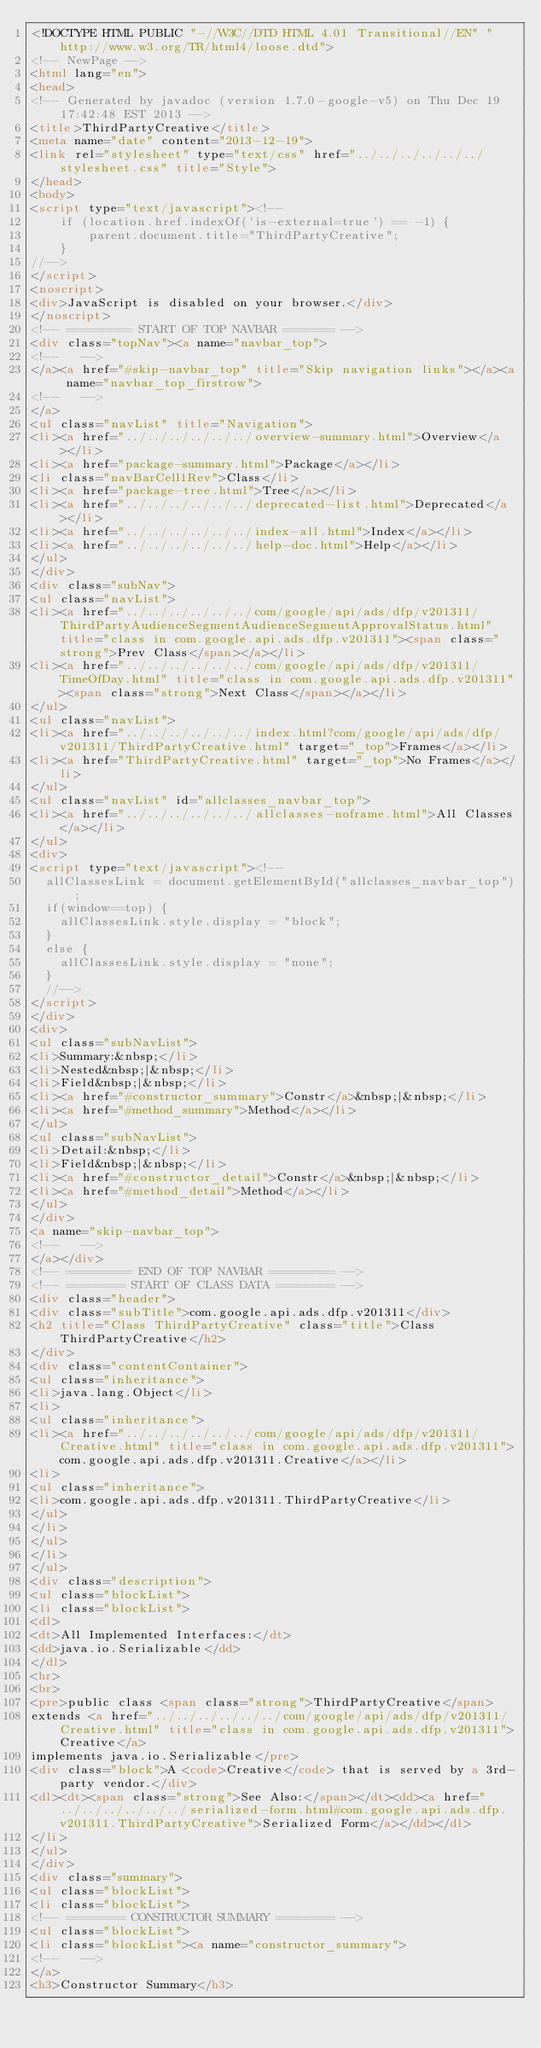<code> <loc_0><loc_0><loc_500><loc_500><_HTML_><!DOCTYPE HTML PUBLIC "-//W3C//DTD HTML 4.01 Transitional//EN" "http://www.w3.org/TR/html4/loose.dtd">
<!-- NewPage -->
<html lang="en">
<head>
<!-- Generated by javadoc (version 1.7.0-google-v5) on Thu Dec 19 17:42:48 EST 2013 -->
<title>ThirdPartyCreative</title>
<meta name="date" content="2013-12-19">
<link rel="stylesheet" type="text/css" href="../../../../../../stylesheet.css" title="Style">
</head>
<body>
<script type="text/javascript"><!--
    if (location.href.indexOf('is-external=true') == -1) {
        parent.document.title="ThirdPartyCreative";
    }
//-->
</script>
<noscript>
<div>JavaScript is disabled on your browser.</div>
</noscript>
<!-- ========= START OF TOP NAVBAR ======= -->
<div class="topNav"><a name="navbar_top">
<!--   -->
</a><a href="#skip-navbar_top" title="Skip navigation links"></a><a name="navbar_top_firstrow">
<!--   -->
</a>
<ul class="navList" title="Navigation">
<li><a href="../../../../../../overview-summary.html">Overview</a></li>
<li><a href="package-summary.html">Package</a></li>
<li class="navBarCell1Rev">Class</li>
<li><a href="package-tree.html">Tree</a></li>
<li><a href="../../../../../../deprecated-list.html">Deprecated</a></li>
<li><a href="../../../../../../index-all.html">Index</a></li>
<li><a href="../../../../../../help-doc.html">Help</a></li>
</ul>
</div>
<div class="subNav">
<ul class="navList">
<li><a href="../../../../../../com/google/api/ads/dfp/v201311/ThirdPartyAudienceSegmentAudienceSegmentApprovalStatus.html" title="class in com.google.api.ads.dfp.v201311"><span class="strong">Prev Class</span></a></li>
<li><a href="../../../../../../com/google/api/ads/dfp/v201311/TimeOfDay.html" title="class in com.google.api.ads.dfp.v201311"><span class="strong">Next Class</span></a></li>
</ul>
<ul class="navList">
<li><a href="../../../../../../index.html?com/google/api/ads/dfp/v201311/ThirdPartyCreative.html" target="_top">Frames</a></li>
<li><a href="ThirdPartyCreative.html" target="_top">No Frames</a></li>
</ul>
<ul class="navList" id="allclasses_navbar_top">
<li><a href="../../../../../../allclasses-noframe.html">All Classes</a></li>
</ul>
<div>
<script type="text/javascript"><!--
  allClassesLink = document.getElementById("allclasses_navbar_top");
  if(window==top) {
    allClassesLink.style.display = "block";
  }
  else {
    allClassesLink.style.display = "none";
  }
  //-->
</script>
</div>
<div>
<ul class="subNavList">
<li>Summary:&nbsp;</li>
<li>Nested&nbsp;|&nbsp;</li>
<li>Field&nbsp;|&nbsp;</li>
<li><a href="#constructor_summary">Constr</a>&nbsp;|&nbsp;</li>
<li><a href="#method_summary">Method</a></li>
</ul>
<ul class="subNavList">
<li>Detail:&nbsp;</li>
<li>Field&nbsp;|&nbsp;</li>
<li><a href="#constructor_detail">Constr</a>&nbsp;|&nbsp;</li>
<li><a href="#method_detail">Method</a></li>
</ul>
</div>
<a name="skip-navbar_top">
<!--   -->
</a></div>
<!-- ========= END OF TOP NAVBAR ========= -->
<!-- ======== START OF CLASS DATA ======== -->
<div class="header">
<div class="subTitle">com.google.api.ads.dfp.v201311</div>
<h2 title="Class ThirdPartyCreative" class="title">Class ThirdPartyCreative</h2>
</div>
<div class="contentContainer">
<ul class="inheritance">
<li>java.lang.Object</li>
<li>
<ul class="inheritance">
<li><a href="../../../../../../com/google/api/ads/dfp/v201311/Creative.html" title="class in com.google.api.ads.dfp.v201311">com.google.api.ads.dfp.v201311.Creative</a></li>
<li>
<ul class="inheritance">
<li>com.google.api.ads.dfp.v201311.ThirdPartyCreative</li>
</ul>
</li>
</ul>
</li>
</ul>
<div class="description">
<ul class="blockList">
<li class="blockList">
<dl>
<dt>All Implemented Interfaces:</dt>
<dd>java.io.Serializable</dd>
</dl>
<hr>
<br>
<pre>public class <span class="strong">ThirdPartyCreative</span>
extends <a href="../../../../../../com/google/api/ads/dfp/v201311/Creative.html" title="class in com.google.api.ads.dfp.v201311">Creative</a>
implements java.io.Serializable</pre>
<div class="block">A <code>Creative</code> that is served by a 3rd-party vendor.</div>
<dl><dt><span class="strong">See Also:</span></dt><dd><a href="../../../../../../serialized-form.html#com.google.api.ads.dfp.v201311.ThirdPartyCreative">Serialized Form</a></dd></dl>
</li>
</ul>
</div>
<div class="summary">
<ul class="blockList">
<li class="blockList">
<!-- ======== CONSTRUCTOR SUMMARY ======== -->
<ul class="blockList">
<li class="blockList"><a name="constructor_summary">
<!--   -->
</a>
<h3>Constructor Summary</h3></code> 